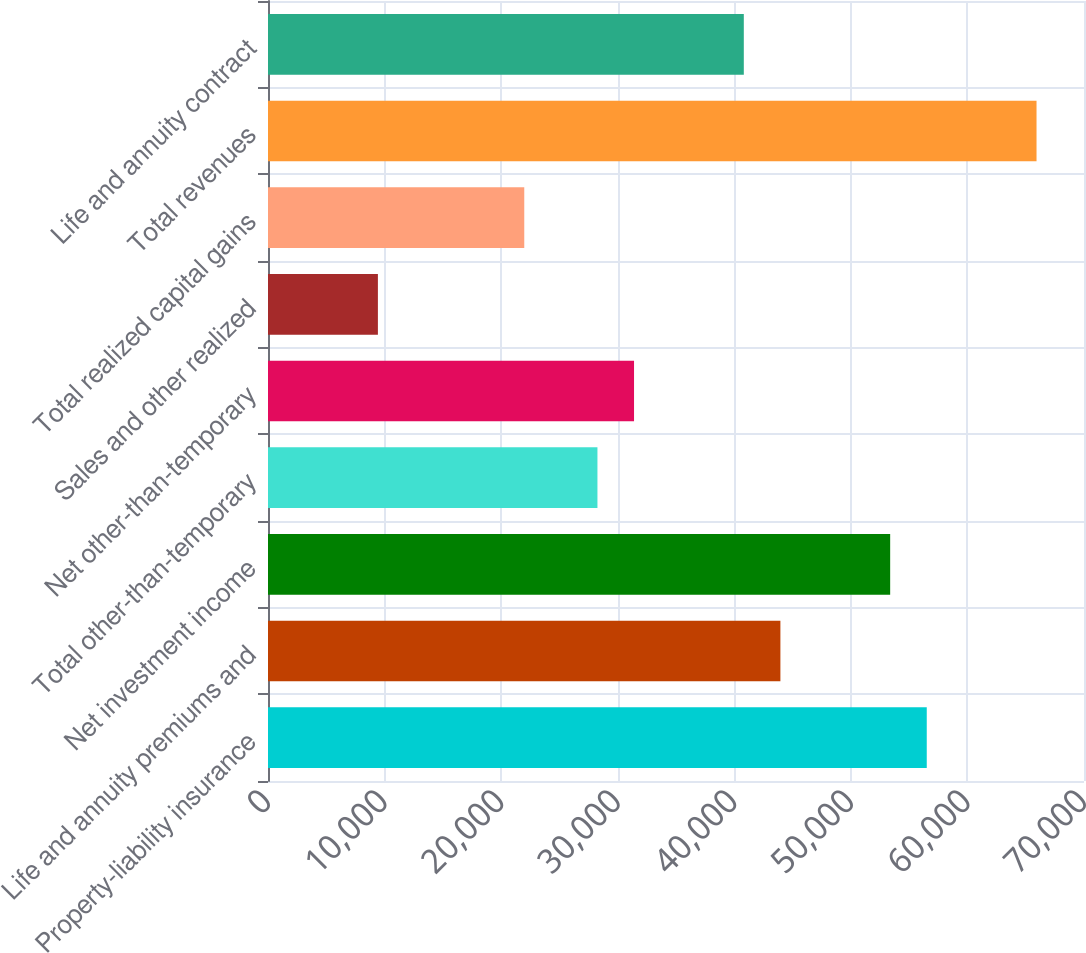<chart> <loc_0><loc_0><loc_500><loc_500><bar_chart><fcel>Property-liability insurance<fcel>Life and annuity premiums and<fcel>Net investment income<fcel>Total other-than-temporary<fcel>Net other-than-temporary<fcel>Sales and other realized<fcel>Total realized capital gains<fcel>Total revenues<fcel>Life and annuity contract<nl><fcel>56511.2<fcel>43955.6<fcel>53372.3<fcel>28261.1<fcel>31400<fcel>9427.7<fcel>21983.3<fcel>65927.9<fcel>40816.7<nl></chart> 